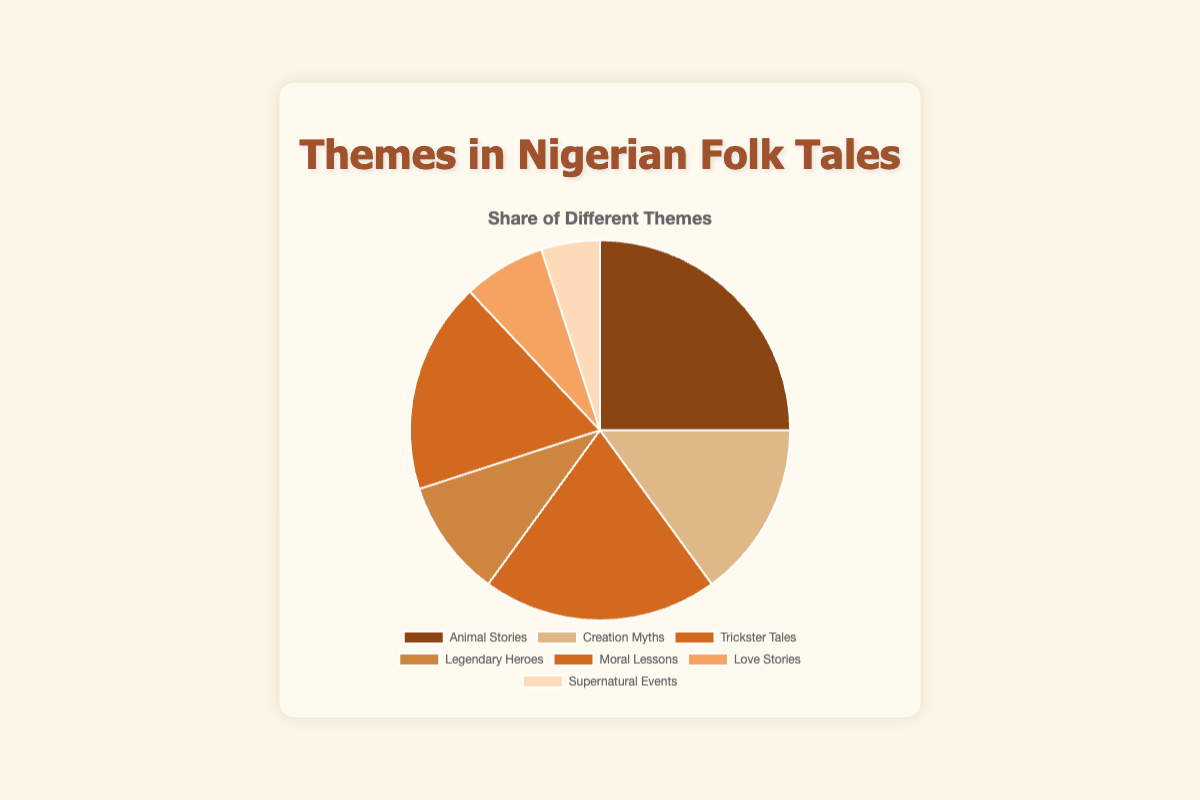What theme has the largest share in Nigerian folk tales? The pie chart shows the proportion of different themes, and the largest section is for "Animal Stories."
Answer: Animal Stories Which theme has the smallest share in Nigerian folk tales? From the pie chart, the smallest section represents "Supernatural Events."
Answer: Supernatural Events How much larger is the share of Animal Stories compared to Creation Myths? The share of Animal Stories is 25%, and Creation Myths is 15%. The difference between them is 25% - 15%.
Answer: 10% What is the combined share of Trickster Tales and Moral Lessons? Trickster Tales have a 20% share, and Moral Lessons have an 18% share. The combined share is 20% + 18%.
Answer: 38% How does the share of Love Stories compare to Legendary Heroes? Love Stories have a 7% share, while Legendary Heroes have a 10% share. So, Legendary Heroes have a larger share.
Answer: Legendary Heroes Which themes combined make up more than half (50%) of the folk tales? Animal Stories (25%), Trickster Tales (20%), and Moral Lessons (18%) combined give 25% + 20% + 18% = 63%, which is more than 50%.
Answer: Animal Stories, Trickster Tales, Moral Lessons By how much does the share of Animal Stories exceed the combined share of Love Stories and Supernatural Events? Animal Stories have a 25% share. Love Stories and Supernatural Events together have 7% + 5% = 12%. The difference is 25% - 12%.
Answer: 13% Which theme has a share closest to one-fifth of the total? One-fifth of the total is 20%. "Trickster Tales" has exactly a 20% share.
Answer: Trickster Tales What is the total share of Creation Myths, Legendary Heroes, and Supernatural Events combined? Creation Myths have a 15% share, Legendary Heroes 10%, and Supernatural Events 5%. The total is 15% + 10% + 5%.
Answer: 30% If you sum the shares of the two themes with the smallest shares, would it be less than 15%? The two themes with the smallest shares are Love Stories (7%) and Supernatural Events (5%). Summing them gives 7% + 5% = 12%, which is less than 15%.
Answer: Yes 